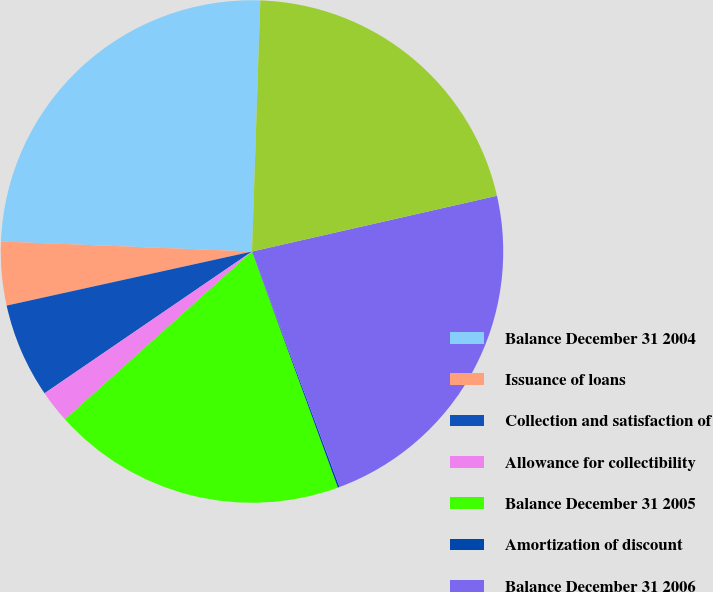Convert chart to OTSL. <chart><loc_0><loc_0><loc_500><loc_500><pie_chart><fcel>Balance December 31 2004<fcel>Issuance of loans<fcel>Collection and satisfaction of<fcel>Allowance for collectibility<fcel>Balance December 31 2005<fcel>Amortization of discount<fcel>Balance December 31 2006<fcel>Balance December 31 2007<nl><fcel>24.89%<fcel>4.09%<fcel>6.09%<fcel>2.1%<fcel>18.91%<fcel>0.11%<fcel>22.9%<fcel>20.91%<nl></chart> 